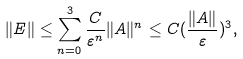<formula> <loc_0><loc_0><loc_500><loc_500>\| E \| \leq \sum _ { n = 0 } ^ { 3 } \frac { C } { \varepsilon ^ { n } } \| A \| ^ { n } \leq C ( \frac { \| A \| } { \varepsilon } ) ^ { 3 } ,</formula> 